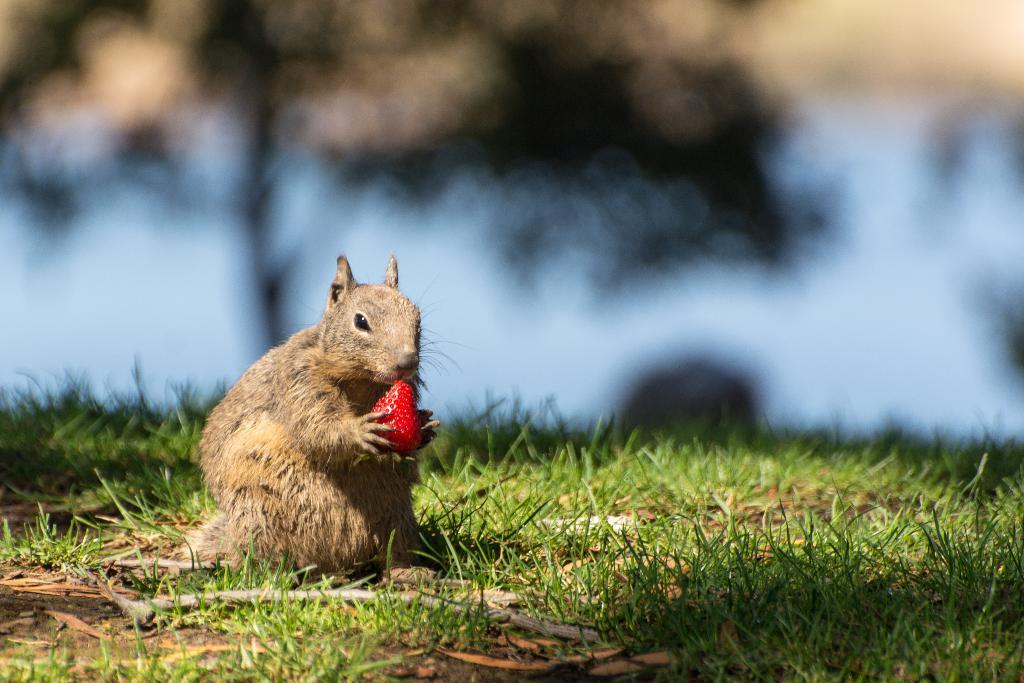What is the main subject of the image? There is a small creature in the image. What is the creature doing in the image? The creature is eating a strawberry. Where is the creature located in the image? The creature is sitting on the grass. Reasoning: Let's think step by following the guidelines to produce the conversation. We start by identifying the main subject of the image, which is the small creature. Then, we describe what the creature is doing, which is eating a strawberry. Finally, we mention the creature's location, which is on the grass. We ensure that each question can be answered definitively with the information given and avoid yes/no questions. Absurd Question/Answer: What type of brass instrument is the creature playing in the image? There is no brass instrument present in the image; the creature is eating a strawberry while sitting on the grass. 